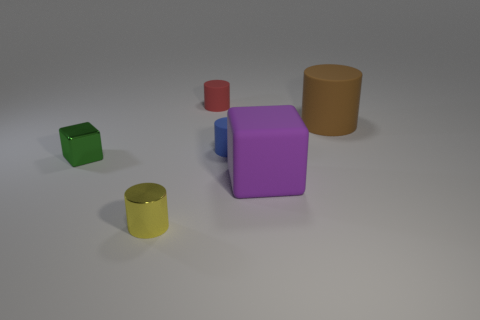Subtract 1 cylinders. How many cylinders are left? 3 Add 1 blue metal things. How many objects exist? 7 Subtract all cylinders. How many objects are left? 2 Subtract 0 blue balls. How many objects are left? 6 Subtract all small green cubes. Subtract all big purple matte things. How many objects are left? 4 Add 6 purple matte objects. How many purple matte objects are left? 7 Add 4 red things. How many red things exist? 5 